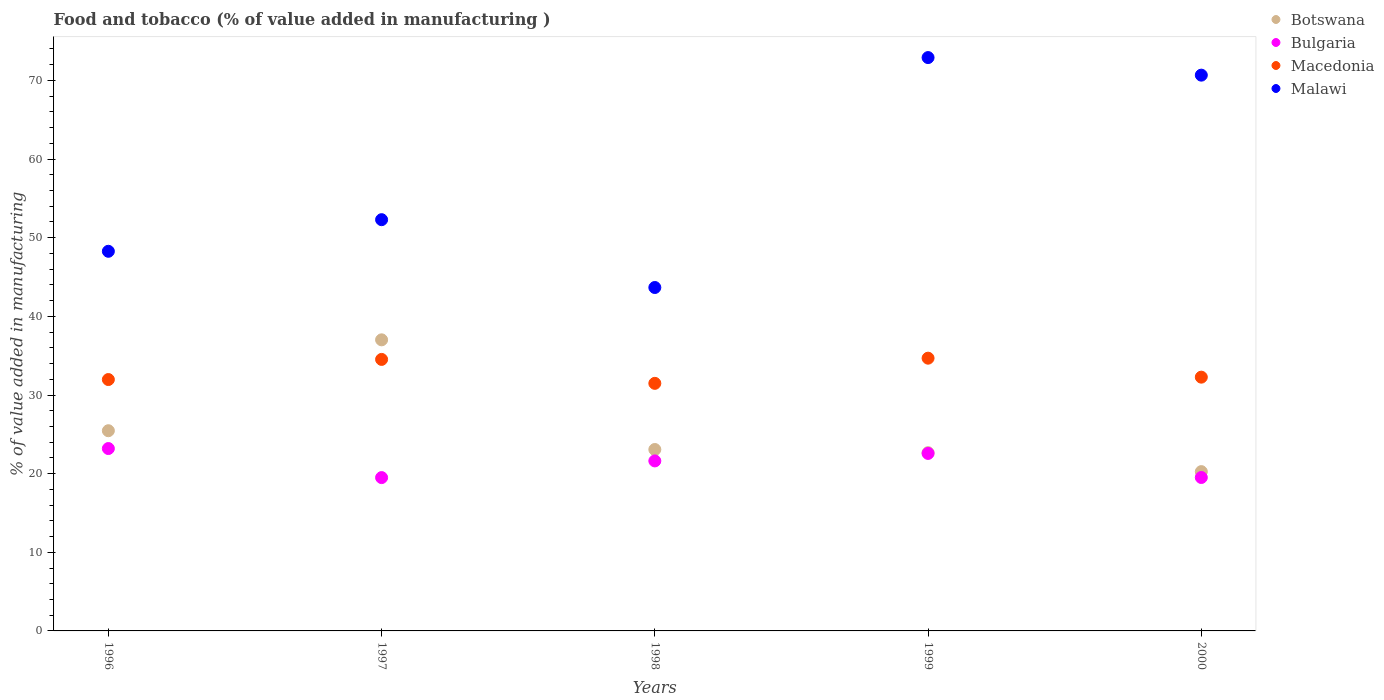Is the number of dotlines equal to the number of legend labels?
Offer a terse response. Yes. What is the value added in manufacturing food and tobacco in Bulgaria in 1999?
Offer a terse response. 22.57. Across all years, what is the maximum value added in manufacturing food and tobacco in Malawi?
Offer a very short reply. 72.91. Across all years, what is the minimum value added in manufacturing food and tobacco in Bulgaria?
Keep it short and to the point. 19.5. In which year was the value added in manufacturing food and tobacco in Macedonia maximum?
Keep it short and to the point. 1999. In which year was the value added in manufacturing food and tobacco in Malawi minimum?
Offer a very short reply. 1998. What is the total value added in manufacturing food and tobacco in Botswana in the graph?
Your answer should be very brief. 128.46. What is the difference between the value added in manufacturing food and tobacco in Macedonia in 1997 and that in 2000?
Offer a very short reply. 2.26. What is the difference between the value added in manufacturing food and tobacco in Bulgaria in 2000 and the value added in manufacturing food and tobacco in Malawi in 1996?
Provide a succinct answer. -28.76. What is the average value added in manufacturing food and tobacco in Bulgaria per year?
Ensure brevity in your answer.  21.28. In the year 1999, what is the difference between the value added in manufacturing food and tobacco in Bulgaria and value added in manufacturing food and tobacco in Malawi?
Make the answer very short. -50.34. What is the ratio of the value added in manufacturing food and tobacco in Bulgaria in 1998 to that in 1999?
Offer a very short reply. 0.96. Is the difference between the value added in manufacturing food and tobacco in Bulgaria in 1997 and 2000 greater than the difference between the value added in manufacturing food and tobacco in Malawi in 1997 and 2000?
Your response must be concise. Yes. What is the difference between the highest and the second highest value added in manufacturing food and tobacco in Botswana?
Your response must be concise. 11.56. What is the difference between the highest and the lowest value added in manufacturing food and tobacco in Malawi?
Your answer should be very brief. 29.24. In how many years, is the value added in manufacturing food and tobacco in Bulgaria greater than the average value added in manufacturing food and tobacco in Bulgaria taken over all years?
Provide a succinct answer. 3. Is it the case that in every year, the sum of the value added in manufacturing food and tobacco in Botswana and value added in manufacturing food and tobacco in Macedonia  is greater than the value added in manufacturing food and tobacco in Malawi?
Give a very brief answer. No. Is the value added in manufacturing food and tobacco in Bulgaria strictly greater than the value added in manufacturing food and tobacco in Malawi over the years?
Your answer should be very brief. No. Is the value added in manufacturing food and tobacco in Macedonia strictly less than the value added in manufacturing food and tobacco in Malawi over the years?
Provide a short and direct response. Yes. How many dotlines are there?
Your answer should be compact. 4. How many years are there in the graph?
Offer a terse response. 5. Are the values on the major ticks of Y-axis written in scientific E-notation?
Your response must be concise. No. Does the graph contain grids?
Keep it short and to the point. No. How are the legend labels stacked?
Provide a short and direct response. Vertical. What is the title of the graph?
Provide a succinct answer. Food and tobacco (% of value added in manufacturing ). Does "Nepal" appear as one of the legend labels in the graph?
Your answer should be very brief. No. What is the label or title of the X-axis?
Keep it short and to the point. Years. What is the label or title of the Y-axis?
Provide a succinct answer. % of value added in manufacturing. What is the % of value added in manufacturing in Botswana in 1996?
Make the answer very short. 25.46. What is the % of value added in manufacturing of Bulgaria in 1996?
Keep it short and to the point. 23.19. What is the % of value added in manufacturing in Macedonia in 1996?
Make the answer very short. 31.97. What is the % of value added in manufacturing in Malawi in 1996?
Make the answer very short. 48.27. What is the % of value added in manufacturing of Botswana in 1997?
Your response must be concise. 37.02. What is the % of value added in manufacturing of Bulgaria in 1997?
Offer a very short reply. 19.5. What is the % of value added in manufacturing in Macedonia in 1997?
Your answer should be very brief. 34.52. What is the % of value added in manufacturing in Malawi in 1997?
Give a very brief answer. 52.29. What is the % of value added in manufacturing in Botswana in 1998?
Your answer should be very brief. 23.07. What is the % of value added in manufacturing in Bulgaria in 1998?
Your answer should be compact. 21.62. What is the % of value added in manufacturing of Macedonia in 1998?
Make the answer very short. 31.48. What is the % of value added in manufacturing in Malawi in 1998?
Your answer should be compact. 43.67. What is the % of value added in manufacturing of Botswana in 1999?
Provide a short and direct response. 22.67. What is the % of value added in manufacturing in Bulgaria in 1999?
Give a very brief answer. 22.57. What is the % of value added in manufacturing of Macedonia in 1999?
Offer a terse response. 34.68. What is the % of value added in manufacturing in Malawi in 1999?
Provide a succinct answer. 72.91. What is the % of value added in manufacturing of Botswana in 2000?
Provide a succinct answer. 20.26. What is the % of value added in manufacturing in Bulgaria in 2000?
Provide a short and direct response. 19.51. What is the % of value added in manufacturing of Macedonia in 2000?
Your answer should be compact. 32.27. What is the % of value added in manufacturing of Malawi in 2000?
Keep it short and to the point. 70.67. Across all years, what is the maximum % of value added in manufacturing in Botswana?
Your response must be concise. 37.02. Across all years, what is the maximum % of value added in manufacturing in Bulgaria?
Offer a very short reply. 23.19. Across all years, what is the maximum % of value added in manufacturing of Macedonia?
Make the answer very short. 34.68. Across all years, what is the maximum % of value added in manufacturing of Malawi?
Provide a short and direct response. 72.91. Across all years, what is the minimum % of value added in manufacturing of Botswana?
Offer a terse response. 20.26. Across all years, what is the minimum % of value added in manufacturing in Bulgaria?
Give a very brief answer. 19.5. Across all years, what is the minimum % of value added in manufacturing in Macedonia?
Your answer should be very brief. 31.48. Across all years, what is the minimum % of value added in manufacturing in Malawi?
Your answer should be very brief. 43.67. What is the total % of value added in manufacturing of Botswana in the graph?
Your answer should be very brief. 128.46. What is the total % of value added in manufacturing of Bulgaria in the graph?
Ensure brevity in your answer.  106.39. What is the total % of value added in manufacturing in Macedonia in the graph?
Provide a succinct answer. 164.92. What is the total % of value added in manufacturing of Malawi in the graph?
Ensure brevity in your answer.  287.82. What is the difference between the % of value added in manufacturing of Botswana in 1996 and that in 1997?
Your answer should be compact. -11.56. What is the difference between the % of value added in manufacturing of Bulgaria in 1996 and that in 1997?
Provide a short and direct response. 3.69. What is the difference between the % of value added in manufacturing in Macedonia in 1996 and that in 1997?
Provide a short and direct response. -2.56. What is the difference between the % of value added in manufacturing of Malawi in 1996 and that in 1997?
Your answer should be very brief. -4.02. What is the difference between the % of value added in manufacturing of Botswana in 1996 and that in 1998?
Offer a terse response. 2.39. What is the difference between the % of value added in manufacturing of Bulgaria in 1996 and that in 1998?
Your answer should be very brief. 1.57. What is the difference between the % of value added in manufacturing of Macedonia in 1996 and that in 1998?
Provide a succinct answer. 0.48. What is the difference between the % of value added in manufacturing in Malawi in 1996 and that in 1998?
Keep it short and to the point. 4.61. What is the difference between the % of value added in manufacturing in Botswana in 1996 and that in 1999?
Provide a succinct answer. 2.79. What is the difference between the % of value added in manufacturing of Bulgaria in 1996 and that in 1999?
Keep it short and to the point. 0.62. What is the difference between the % of value added in manufacturing in Macedonia in 1996 and that in 1999?
Ensure brevity in your answer.  -2.72. What is the difference between the % of value added in manufacturing in Malawi in 1996 and that in 1999?
Your answer should be very brief. -24.63. What is the difference between the % of value added in manufacturing in Botswana in 1996 and that in 2000?
Your answer should be compact. 5.2. What is the difference between the % of value added in manufacturing of Bulgaria in 1996 and that in 2000?
Offer a terse response. 3.68. What is the difference between the % of value added in manufacturing in Macedonia in 1996 and that in 2000?
Provide a short and direct response. -0.3. What is the difference between the % of value added in manufacturing of Malawi in 1996 and that in 2000?
Offer a terse response. -22.4. What is the difference between the % of value added in manufacturing of Botswana in 1997 and that in 1998?
Give a very brief answer. 13.95. What is the difference between the % of value added in manufacturing of Bulgaria in 1997 and that in 1998?
Offer a very short reply. -2.12. What is the difference between the % of value added in manufacturing in Macedonia in 1997 and that in 1998?
Provide a succinct answer. 3.04. What is the difference between the % of value added in manufacturing in Malawi in 1997 and that in 1998?
Ensure brevity in your answer.  8.62. What is the difference between the % of value added in manufacturing in Botswana in 1997 and that in 1999?
Ensure brevity in your answer.  14.35. What is the difference between the % of value added in manufacturing of Bulgaria in 1997 and that in 1999?
Provide a succinct answer. -3.07. What is the difference between the % of value added in manufacturing of Macedonia in 1997 and that in 1999?
Offer a very short reply. -0.16. What is the difference between the % of value added in manufacturing of Malawi in 1997 and that in 1999?
Give a very brief answer. -20.61. What is the difference between the % of value added in manufacturing in Botswana in 1997 and that in 2000?
Offer a terse response. 16.76. What is the difference between the % of value added in manufacturing in Bulgaria in 1997 and that in 2000?
Your response must be concise. -0.01. What is the difference between the % of value added in manufacturing of Macedonia in 1997 and that in 2000?
Keep it short and to the point. 2.26. What is the difference between the % of value added in manufacturing of Malawi in 1997 and that in 2000?
Offer a very short reply. -18.38. What is the difference between the % of value added in manufacturing in Botswana in 1998 and that in 1999?
Keep it short and to the point. 0.4. What is the difference between the % of value added in manufacturing of Bulgaria in 1998 and that in 1999?
Provide a short and direct response. -0.95. What is the difference between the % of value added in manufacturing in Macedonia in 1998 and that in 1999?
Offer a terse response. -3.2. What is the difference between the % of value added in manufacturing of Malawi in 1998 and that in 1999?
Your response must be concise. -29.24. What is the difference between the % of value added in manufacturing in Botswana in 1998 and that in 2000?
Ensure brevity in your answer.  2.81. What is the difference between the % of value added in manufacturing of Bulgaria in 1998 and that in 2000?
Ensure brevity in your answer.  2.11. What is the difference between the % of value added in manufacturing in Macedonia in 1998 and that in 2000?
Ensure brevity in your answer.  -0.79. What is the difference between the % of value added in manufacturing in Malawi in 1998 and that in 2000?
Your answer should be compact. -27. What is the difference between the % of value added in manufacturing of Botswana in 1999 and that in 2000?
Make the answer very short. 2.41. What is the difference between the % of value added in manufacturing in Bulgaria in 1999 and that in 2000?
Keep it short and to the point. 3.06. What is the difference between the % of value added in manufacturing of Macedonia in 1999 and that in 2000?
Keep it short and to the point. 2.41. What is the difference between the % of value added in manufacturing of Malawi in 1999 and that in 2000?
Offer a terse response. 2.23. What is the difference between the % of value added in manufacturing of Botswana in 1996 and the % of value added in manufacturing of Bulgaria in 1997?
Your answer should be compact. 5.96. What is the difference between the % of value added in manufacturing in Botswana in 1996 and the % of value added in manufacturing in Macedonia in 1997?
Provide a succinct answer. -9.07. What is the difference between the % of value added in manufacturing of Botswana in 1996 and the % of value added in manufacturing of Malawi in 1997?
Ensure brevity in your answer.  -26.84. What is the difference between the % of value added in manufacturing of Bulgaria in 1996 and the % of value added in manufacturing of Macedonia in 1997?
Make the answer very short. -11.33. What is the difference between the % of value added in manufacturing in Bulgaria in 1996 and the % of value added in manufacturing in Malawi in 1997?
Your answer should be very brief. -29.1. What is the difference between the % of value added in manufacturing in Macedonia in 1996 and the % of value added in manufacturing in Malawi in 1997?
Offer a terse response. -20.33. What is the difference between the % of value added in manufacturing of Botswana in 1996 and the % of value added in manufacturing of Bulgaria in 1998?
Your response must be concise. 3.84. What is the difference between the % of value added in manufacturing of Botswana in 1996 and the % of value added in manufacturing of Macedonia in 1998?
Keep it short and to the point. -6.02. What is the difference between the % of value added in manufacturing in Botswana in 1996 and the % of value added in manufacturing in Malawi in 1998?
Your response must be concise. -18.21. What is the difference between the % of value added in manufacturing in Bulgaria in 1996 and the % of value added in manufacturing in Macedonia in 1998?
Provide a short and direct response. -8.29. What is the difference between the % of value added in manufacturing in Bulgaria in 1996 and the % of value added in manufacturing in Malawi in 1998?
Keep it short and to the point. -20.48. What is the difference between the % of value added in manufacturing of Macedonia in 1996 and the % of value added in manufacturing of Malawi in 1998?
Your response must be concise. -11.7. What is the difference between the % of value added in manufacturing in Botswana in 1996 and the % of value added in manufacturing in Bulgaria in 1999?
Your response must be concise. 2.89. What is the difference between the % of value added in manufacturing in Botswana in 1996 and the % of value added in manufacturing in Macedonia in 1999?
Offer a terse response. -9.22. What is the difference between the % of value added in manufacturing in Botswana in 1996 and the % of value added in manufacturing in Malawi in 1999?
Provide a succinct answer. -47.45. What is the difference between the % of value added in manufacturing in Bulgaria in 1996 and the % of value added in manufacturing in Macedonia in 1999?
Offer a terse response. -11.49. What is the difference between the % of value added in manufacturing of Bulgaria in 1996 and the % of value added in manufacturing of Malawi in 1999?
Offer a terse response. -49.72. What is the difference between the % of value added in manufacturing of Macedonia in 1996 and the % of value added in manufacturing of Malawi in 1999?
Provide a short and direct response. -40.94. What is the difference between the % of value added in manufacturing in Botswana in 1996 and the % of value added in manufacturing in Bulgaria in 2000?
Offer a very short reply. 5.95. What is the difference between the % of value added in manufacturing in Botswana in 1996 and the % of value added in manufacturing in Macedonia in 2000?
Offer a terse response. -6.81. What is the difference between the % of value added in manufacturing in Botswana in 1996 and the % of value added in manufacturing in Malawi in 2000?
Offer a terse response. -45.22. What is the difference between the % of value added in manufacturing of Bulgaria in 1996 and the % of value added in manufacturing of Macedonia in 2000?
Your answer should be compact. -9.08. What is the difference between the % of value added in manufacturing in Bulgaria in 1996 and the % of value added in manufacturing in Malawi in 2000?
Offer a very short reply. -47.48. What is the difference between the % of value added in manufacturing in Macedonia in 1996 and the % of value added in manufacturing in Malawi in 2000?
Provide a succinct answer. -38.71. What is the difference between the % of value added in manufacturing of Botswana in 1997 and the % of value added in manufacturing of Bulgaria in 1998?
Provide a succinct answer. 15.4. What is the difference between the % of value added in manufacturing of Botswana in 1997 and the % of value added in manufacturing of Macedonia in 1998?
Provide a succinct answer. 5.53. What is the difference between the % of value added in manufacturing of Botswana in 1997 and the % of value added in manufacturing of Malawi in 1998?
Make the answer very short. -6.65. What is the difference between the % of value added in manufacturing of Bulgaria in 1997 and the % of value added in manufacturing of Macedonia in 1998?
Give a very brief answer. -11.98. What is the difference between the % of value added in manufacturing in Bulgaria in 1997 and the % of value added in manufacturing in Malawi in 1998?
Offer a terse response. -24.17. What is the difference between the % of value added in manufacturing of Macedonia in 1997 and the % of value added in manufacturing of Malawi in 1998?
Give a very brief answer. -9.14. What is the difference between the % of value added in manufacturing in Botswana in 1997 and the % of value added in manufacturing in Bulgaria in 1999?
Offer a terse response. 14.44. What is the difference between the % of value added in manufacturing of Botswana in 1997 and the % of value added in manufacturing of Macedonia in 1999?
Your response must be concise. 2.33. What is the difference between the % of value added in manufacturing of Botswana in 1997 and the % of value added in manufacturing of Malawi in 1999?
Your answer should be very brief. -35.89. What is the difference between the % of value added in manufacturing in Bulgaria in 1997 and the % of value added in manufacturing in Macedonia in 1999?
Your answer should be compact. -15.19. What is the difference between the % of value added in manufacturing of Bulgaria in 1997 and the % of value added in manufacturing of Malawi in 1999?
Provide a short and direct response. -53.41. What is the difference between the % of value added in manufacturing of Macedonia in 1997 and the % of value added in manufacturing of Malawi in 1999?
Keep it short and to the point. -38.38. What is the difference between the % of value added in manufacturing in Botswana in 1997 and the % of value added in manufacturing in Bulgaria in 2000?
Provide a succinct answer. 17.5. What is the difference between the % of value added in manufacturing of Botswana in 1997 and the % of value added in manufacturing of Macedonia in 2000?
Keep it short and to the point. 4.75. What is the difference between the % of value added in manufacturing in Botswana in 1997 and the % of value added in manufacturing in Malawi in 2000?
Give a very brief answer. -33.66. What is the difference between the % of value added in manufacturing of Bulgaria in 1997 and the % of value added in manufacturing of Macedonia in 2000?
Keep it short and to the point. -12.77. What is the difference between the % of value added in manufacturing in Bulgaria in 1997 and the % of value added in manufacturing in Malawi in 2000?
Your answer should be compact. -51.18. What is the difference between the % of value added in manufacturing of Macedonia in 1997 and the % of value added in manufacturing of Malawi in 2000?
Your response must be concise. -36.15. What is the difference between the % of value added in manufacturing in Botswana in 1998 and the % of value added in manufacturing in Bulgaria in 1999?
Your response must be concise. 0.5. What is the difference between the % of value added in manufacturing of Botswana in 1998 and the % of value added in manufacturing of Macedonia in 1999?
Your answer should be compact. -11.61. What is the difference between the % of value added in manufacturing of Botswana in 1998 and the % of value added in manufacturing of Malawi in 1999?
Your response must be concise. -49.84. What is the difference between the % of value added in manufacturing of Bulgaria in 1998 and the % of value added in manufacturing of Macedonia in 1999?
Provide a short and direct response. -13.06. What is the difference between the % of value added in manufacturing in Bulgaria in 1998 and the % of value added in manufacturing in Malawi in 1999?
Keep it short and to the point. -51.29. What is the difference between the % of value added in manufacturing in Macedonia in 1998 and the % of value added in manufacturing in Malawi in 1999?
Provide a succinct answer. -41.43. What is the difference between the % of value added in manufacturing in Botswana in 1998 and the % of value added in manufacturing in Bulgaria in 2000?
Provide a succinct answer. 3.56. What is the difference between the % of value added in manufacturing of Botswana in 1998 and the % of value added in manufacturing of Macedonia in 2000?
Offer a very short reply. -9.2. What is the difference between the % of value added in manufacturing of Botswana in 1998 and the % of value added in manufacturing of Malawi in 2000?
Keep it short and to the point. -47.6. What is the difference between the % of value added in manufacturing of Bulgaria in 1998 and the % of value added in manufacturing of Macedonia in 2000?
Your response must be concise. -10.65. What is the difference between the % of value added in manufacturing of Bulgaria in 1998 and the % of value added in manufacturing of Malawi in 2000?
Ensure brevity in your answer.  -49.06. What is the difference between the % of value added in manufacturing of Macedonia in 1998 and the % of value added in manufacturing of Malawi in 2000?
Your answer should be very brief. -39.19. What is the difference between the % of value added in manufacturing in Botswana in 1999 and the % of value added in manufacturing in Bulgaria in 2000?
Provide a succinct answer. 3.15. What is the difference between the % of value added in manufacturing of Botswana in 1999 and the % of value added in manufacturing of Macedonia in 2000?
Ensure brevity in your answer.  -9.6. What is the difference between the % of value added in manufacturing of Botswana in 1999 and the % of value added in manufacturing of Malawi in 2000?
Your answer should be very brief. -48.01. What is the difference between the % of value added in manufacturing of Bulgaria in 1999 and the % of value added in manufacturing of Macedonia in 2000?
Ensure brevity in your answer.  -9.7. What is the difference between the % of value added in manufacturing in Bulgaria in 1999 and the % of value added in manufacturing in Malawi in 2000?
Provide a succinct answer. -48.1. What is the difference between the % of value added in manufacturing in Macedonia in 1999 and the % of value added in manufacturing in Malawi in 2000?
Provide a succinct answer. -35.99. What is the average % of value added in manufacturing of Botswana per year?
Your answer should be compact. 25.69. What is the average % of value added in manufacturing in Bulgaria per year?
Ensure brevity in your answer.  21.28. What is the average % of value added in manufacturing in Macedonia per year?
Make the answer very short. 32.98. What is the average % of value added in manufacturing of Malawi per year?
Offer a terse response. 57.56. In the year 1996, what is the difference between the % of value added in manufacturing of Botswana and % of value added in manufacturing of Bulgaria?
Your answer should be very brief. 2.27. In the year 1996, what is the difference between the % of value added in manufacturing of Botswana and % of value added in manufacturing of Macedonia?
Provide a short and direct response. -6.51. In the year 1996, what is the difference between the % of value added in manufacturing of Botswana and % of value added in manufacturing of Malawi?
Give a very brief answer. -22.82. In the year 1996, what is the difference between the % of value added in manufacturing of Bulgaria and % of value added in manufacturing of Macedonia?
Provide a short and direct response. -8.77. In the year 1996, what is the difference between the % of value added in manufacturing of Bulgaria and % of value added in manufacturing of Malawi?
Offer a very short reply. -25.08. In the year 1996, what is the difference between the % of value added in manufacturing of Macedonia and % of value added in manufacturing of Malawi?
Provide a succinct answer. -16.31. In the year 1997, what is the difference between the % of value added in manufacturing in Botswana and % of value added in manufacturing in Bulgaria?
Offer a very short reply. 17.52. In the year 1997, what is the difference between the % of value added in manufacturing of Botswana and % of value added in manufacturing of Macedonia?
Offer a terse response. 2.49. In the year 1997, what is the difference between the % of value added in manufacturing of Botswana and % of value added in manufacturing of Malawi?
Provide a short and direct response. -15.28. In the year 1997, what is the difference between the % of value added in manufacturing in Bulgaria and % of value added in manufacturing in Macedonia?
Your response must be concise. -15.03. In the year 1997, what is the difference between the % of value added in manufacturing of Bulgaria and % of value added in manufacturing of Malawi?
Provide a succinct answer. -32.8. In the year 1997, what is the difference between the % of value added in manufacturing of Macedonia and % of value added in manufacturing of Malawi?
Give a very brief answer. -17.77. In the year 1998, what is the difference between the % of value added in manufacturing in Botswana and % of value added in manufacturing in Bulgaria?
Your answer should be compact. 1.45. In the year 1998, what is the difference between the % of value added in manufacturing of Botswana and % of value added in manufacturing of Macedonia?
Give a very brief answer. -8.41. In the year 1998, what is the difference between the % of value added in manufacturing in Botswana and % of value added in manufacturing in Malawi?
Your answer should be compact. -20.6. In the year 1998, what is the difference between the % of value added in manufacturing of Bulgaria and % of value added in manufacturing of Macedonia?
Ensure brevity in your answer.  -9.86. In the year 1998, what is the difference between the % of value added in manufacturing in Bulgaria and % of value added in manufacturing in Malawi?
Your answer should be very brief. -22.05. In the year 1998, what is the difference between the % of value added in manufacturing of Macedonia and % of value added in manufacturing of Malawi?
Make the answer very short. -12.19. In the year 1999, what is the difference between the % of value added in manufacturing in Botswana and % of value added in manufacturing in Bulgaria?
Ensure brevity in your answer.  0.1. In the year 1999, what is the difference between the % of value added in manufacturing in Botswana and % of value added in manufacturing in Macedonia?
Offer a very short reply. -12.02. In the year 1999, what is the difference between the % of value added in manufacturing of Botswana and % of value added in manufacturing of Malawi?
Your answer should be compact. -50.24. In the year 1999, what is the difference between the % of value added in manufacturing in Bulgaria and % of value added in manufacturing in Macedonia?
Make the answer very short. -12.11. In the year 1999, what is the difference between the % of value added in manufacturing of Bulgaria and % of value added in manufacturing of Malawi?
Give a very brief answer. -50.34. In the year 1999, what is the difference between the % of value added in manufacturing in Macedonia and % of value added in manufacturing in Malawi?
Provide a succinct answer. -38.22. In the year 2000, what is the difference between the % of value added in manufacturing of Botswana and % of value added in manufacturing of Bulgaria?
Offer a very short reply. 0.74. In the year 2000, what is the difference between the % of value added in manufacturing in Botswana and % of value added in manufacturing in Macedonia?
Give a very brief answer. -12.01. In the year 2000, what is the difference between the % of value added in manufacturing of Botswana and % of value added in manufacturing of Malawi?
Offer a very short reply. -50.42. In the year 2000, what is the difference between the % of value added in manufacturing of Bulgaria and % of value added in manufacturing of Macedonia?
Offer a very short reply. -12.76. In the year 2000, what is the difference between the % of value added in manufacturing of Bulgaria and % of value added in manufacturing of Malawi?
Your answer should be very brief. -51.16. In the year 2000, what is the difference between the % of value added in manufacturing in Macedonia and % of value added in manufacturing in Malawi?
Provide a succinct answer. -38.4. What is the ratio of the % of value added in manufacturing in Botswana in 1996 to that in 1997?
Make the answer very short. 0.69. What is the ratio of the % of value added in manufacturing of Bulgaria in 1996 to that in 1997?
Make the answer very short. 1.19. What is the ratio of the % of value added in manufacturing in Macedonia in 1996 to that in 1997?
Your answer should be very brief. 0.93. What is the ratio of the % of value added in manufacturing of Malawi in 1996 to that in 1997?
Provide a succinct answer. 0.92. What is the ratio of the % of value added in manufacturing in Botswana in 1996 to that in 1998?
Ensure brevity in your answer.  1.1. What is the ratio of the % of value added in manufacturing of Bulgaria in 1996 to that in 1998?
Keep it short and to the point. 1.07. What is the ratio of the % of value added in manufacturing of Macedonia in 1996 to that in 1998?
Your response must be concise. 1.02. What is the ratio of the % of value added in manufacturing of Malawi in 1996 to that in 1998?
Provide a succinct answer. 1.11. What is the ratio of the % of value added in manufacturing of Botswana in 1996 to that in 1999?
Ensure brevity in your answer.  1.12. What is the ratio of the % of value added in manufacturing of Bulgaria in 1996 to that in 1999?
Offer a terse response. 1.03. What is the ratio of the % of value added in manufacturing of Macedonia in 1996 to that in 1999?
Offer a very short reply. 0.92. What is the ratio of the % of value added in manufacturing in Malawi in 1996 to that in 1999?
Give a very brief answer. 0.66. What is the ratio of the % of value added in manufacturing in Botswana in 1996 to that in 2000?
Offer a terse response. 1.26. What is the ratio of the % of value added in manufacturing in Bulgaria in 1996 to that in 2000?
Make the answer very short. 1.19. What is the ratio of the % of value added in manufacturing of Macedonia in 1996 to that in 2000?
Give a very brief answer. 0.99. What is the ratio of the % of value added in manufacturing in Malawi in 1996 to that in 2000?
Offer a very short reply. 0.68. What is the ratio of the % of value added in manufacturing in Botswana in 1997 to that in 1998?
Your answer should be compact. 1.6. What is the ratio of the % of value added in manufacturing of Bulgaria in 1997 to that in 1998?
Ensure brevity in your answer.  0.9. What is the ratio of the % of value added in manufacturing of Macedonia in 1997 to that in 1998?
Offer a very short reply. 1.1. What is the ratio of the % of value added in manufacturing in Malawi in 1997 to that in 1998?
Ensure brevity in your answer.  1.2. What is the ratio of the % of value added in manufacturing in Botswana in 1997 to that in 1999?
Your answer should be compact. 1.63. What is the ratio of the % of value added in manufacturing of Bulgaria in 1997 to that in 1999?
Give a very brief answer. 0.86. What is the ratio of the % of value added in manufacturing in Macedonia in 1997 to that in 1999?
Your response must be concise. 1. What is the ratio of the % of value added in manufacturing in Malawi in 1997 to that in 1999?
Offer a terse response. 0.72. What is the ratio of the % of value added in manufacturing in Botswana in 1997 to that in 2000?
Keep it short and to the point. 1.83. What is the ratio of the % of value added in manufacturing of Bulgaria in 1997 to that in 2000?
Offer a terse response. 1. What is the ratio of the % of value added in manufacturing of Macedonia in 1997 to that in 2000?
Your response must be concise. 1.07. What is the ratio of the % of value added in manufacturing in Malawi in 1997 to that in 2000?
Provide a succinct answer. 0.74. What is the ratio of the % of value added in manufacturing of Botswana in 1998 to that in 1999?
Provide a succinct answer. 1.02. What is the ratio of the % of value added in manufacturing in Bulgaria in 1998 to that in 1999?
Provide a succinct answer. 0.96. What is the ratio of the % of value added in manufacturing in Macedonia in 1998 to that in 1999?
Your answer should be compact. 0.91. What is the ratio of the % of value added in manufacturing of Malawi in 1998 to that in 1999?
Your response must be concise. 0.6. What is the ratio of the % of value added in manufacturing of Botswana in 1998 to that in 2000?
Ensure brevity in your answer.  1.14. What is the ratio of the % of value added in manufacturing of Bulgaria in 1998 to that in 2000?
Provide a succinct answer. 1.11. What is the ratio of the % of value added in manufacturing of Macedonia in 1998 to that in 2000?
Offer a very short reply. 0.98. What is the ratio of the % of value added in manufacturing in Malawi in 1998 to that in 2000?
Provide a short and direct response. 0.62. What is the ratio of the % of value added in manufacturing in Botswana in 1999 to that in 2000?
Offer a very short reply. 1.12. What is the ratio of the % of value added in manufacturing of Bulgaria in 1999 to that in 2000?
Provide a succinct answer. 1.16. What is the ratio of the % of value added in manufacturing in Macedonia in 1999 to that in 2000?
Your answer should be very brief. 1.07. What is the ratio of the % of value added in manufacturing in Malawi in 1999 to that in 2000?
Ensure brevity in your answer.  1.03. What is the difference between the highest and the second highest % of value added in manufacturing in Botswana?
Provide a succinct answer. 11.56. What is the difference between the highest and the second highest % of value added in manufacturing of Bulgaria?
Provide a short and direct response. 0.62. What is the difference between the highest and the second highest % of value added in manufacturing of Macedonia?
Your answer should be very brief. 0.16. What is the difference between the highest and the second highest % of value added in manufacturing in Malawi?
Your answer should be very brief. 2.23. What is the difference between the highest and the lowest % of value added in manufacturing in Botswana?
Provide a succinct answer. 16.76. What is the difference between the highest and the lowest % of value added in manufacturing of Bulgaria?
Ensure brevity in your answer.  3.69. What is the difference between the highest and the lowest % of value added in manufacturing in Macedonia?
Give a very brief answer. 3.2. What is the difference between the highest and the lowest % of value added in manufacturing in Malawi?
Offer a very short reply. 29.24. 